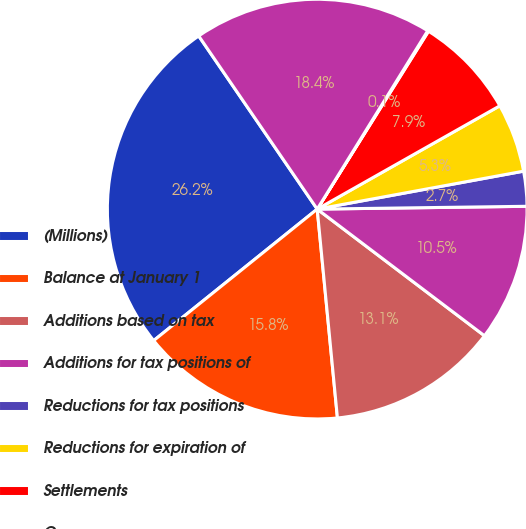Convert chart. <chart><loc_0><loc_0><loc_500><loc_500><pie_chart><fcel>(Millions)<fcel>Balance at January 1<fcel>Additions based on tax<fcel>Additions for tax positions of<fcel>Reductions for tax positions<fcel>Reductions for expiration of<fcel>Settlements<fcel>Currency<fcel>Balance at December 31<nl><fcel>26.23%<fcel>15.76%<fcel>13.15%<fcel>10.53%<fcel>2.68%<fcel>5.3%<fcel>7.91%<fcel>0.07%<fcel>18.38%<nl></chart> 